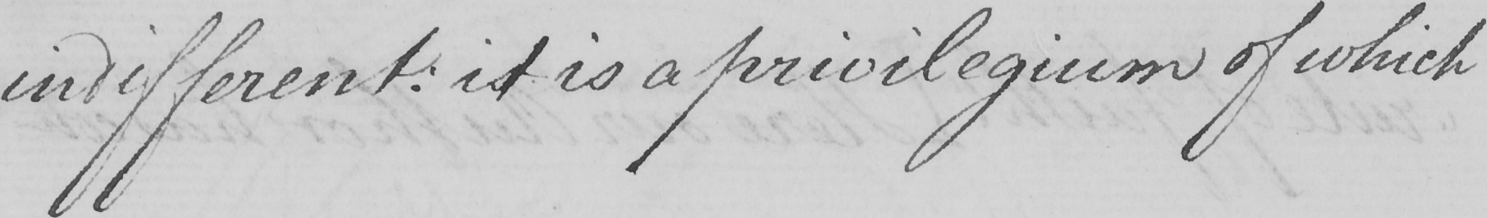Can you tell me what this handwritten text says? indifferent :  it is a privilegium of which 